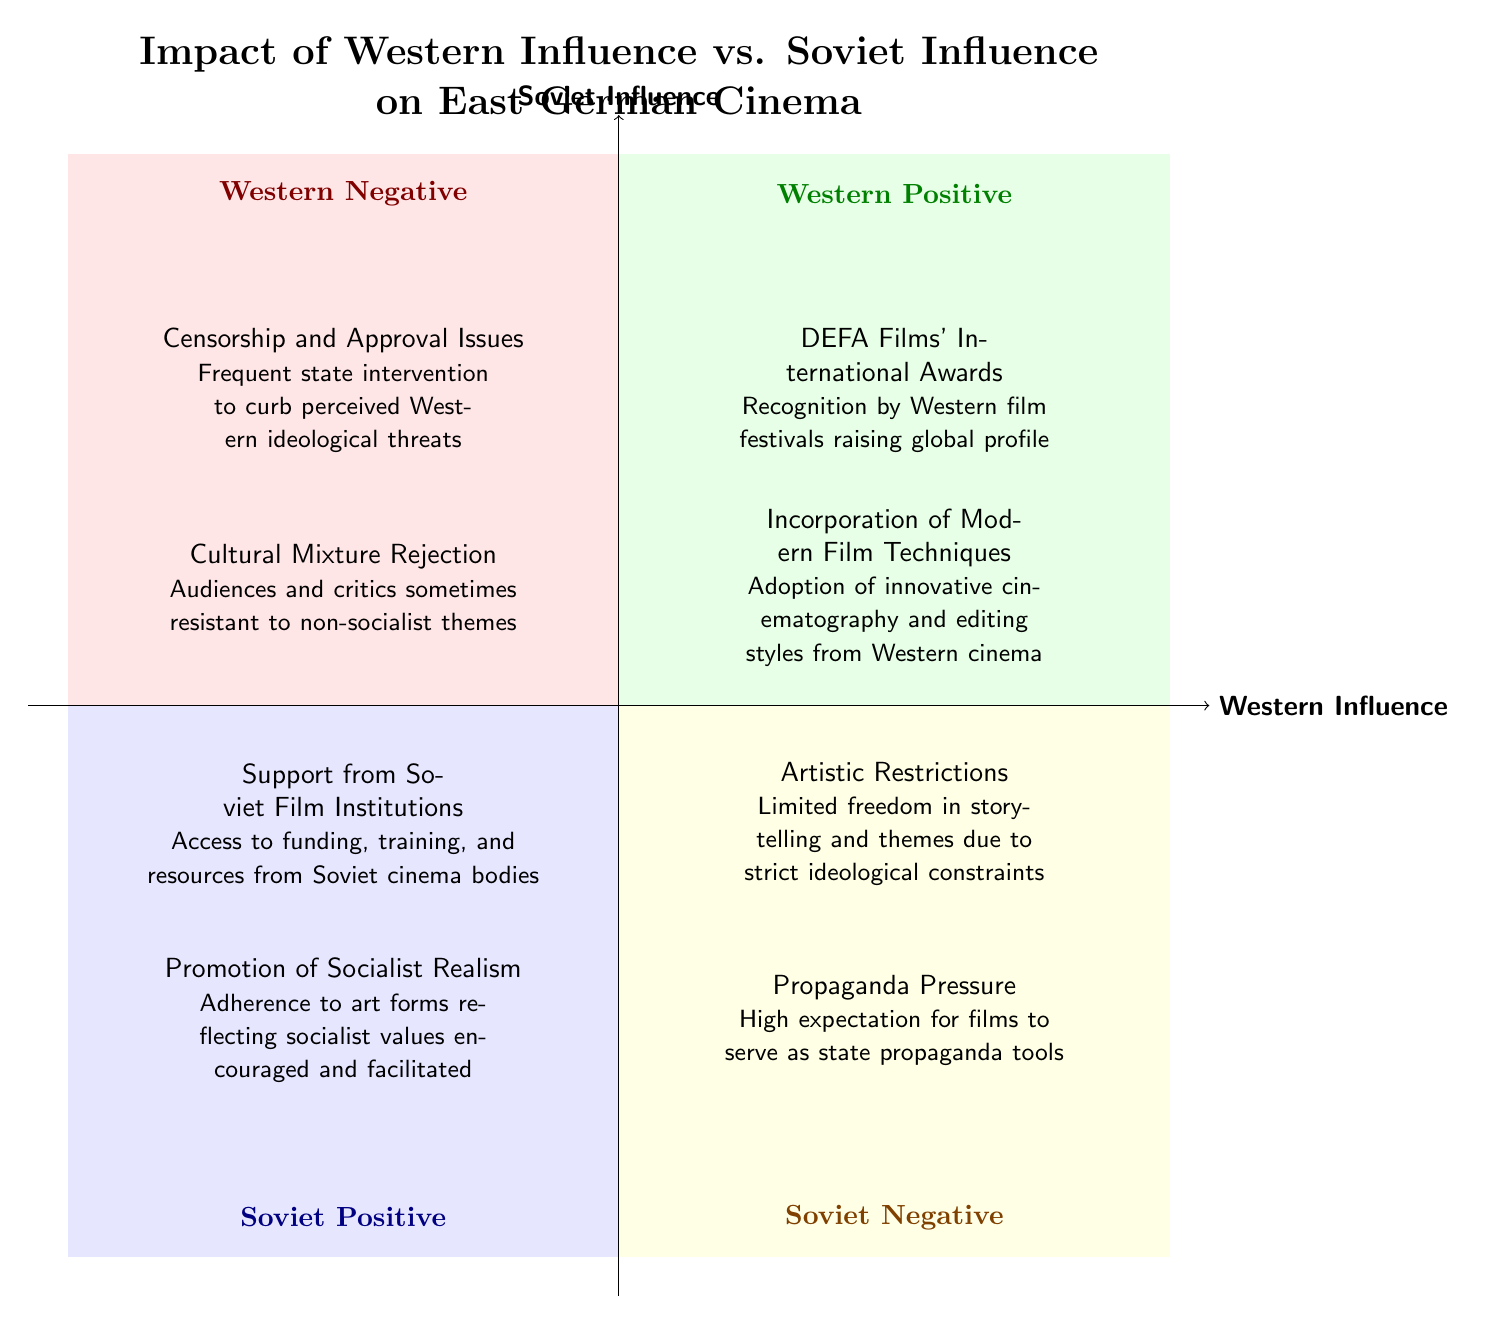What are the two elements in the Western Positive quadrant? The Western Positive quadrant contains two elements: "DEFA Films' International Awards" and "Incorporation of Modern Film Techniques." These can be found listed within the designated quadrant area of the diagram.
Answer: DEFA Films' International Awards, Incorporation of Modern Film Techniques What type of film funding support was provided by Soviet institutions? In the Soviet Positive quadrant, one of the elements mentions "Support from Soviet Film Institutions," which describes the access to funding, training, and resources provided to East German filmmakers.
Answer: Support from Soviet Film Institutions How many elements describe the Western Negative influences on East German cinema? There are two elements listed within the Western Negative quadrant: "Censorship and Approval Issues" and "Cultural Mixture Rejection." Therefore, the count is two.
Answer: 2 Which quadrant includes the element "Artistic Restrictions"? "Artistic Restrictions" is located in the Soviet Negative quadrant, which features two elements focused on the limitations imposed on East German cinema due to ideological constraints.
Answer: Soviet Negative What common theme centers the elements in the Soviet Negative quadrant? The elements in the Soviet Negative quadrant revolve around restrictions placed on filmmakers, specifically "Artistic Restrictions" and "Propaganda Pressure," indicating limitations in creative freedom.
Answer: Restrictions What is the significance of "Incorporation of Modern Film Techniques" in relation to Western Influence? "Incorporation of Modern Film Techniques" highlights how East German cinema adopted innovative practices from Western cinema, illustrating the positive influence of Western filmmaking on DEFA films.
Answer: Positive influence Which quadrant has elements associated with ideological pressures? Both the Soviet Negative quadrant (via "Propaganda Pressure") and the Western Negative quadrant (via "Censorship and Approval Issues") address ideological pressures affecting East German filmmaking.
Answer: Soviet Negative, Western Negative What is the primary focus of the elements in the Soviet Positive quadrant? The Soviet Positive quadrant primarily focuses on the support provided by Soviet institutions for the film industry, emphasizing themes of funding and the promotion of socialist values in cinema.
Answer: Support and promotion 